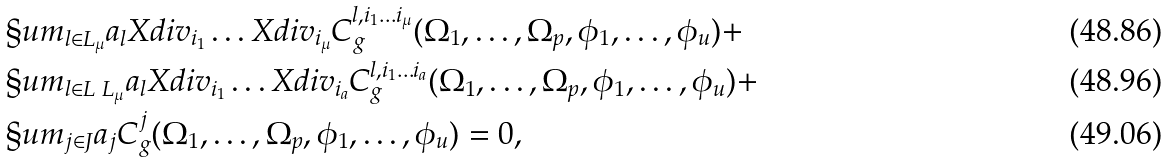Convert formula to latex. <formula><loc_0><loc_0><loc_500><loc_500>& \S u m _ { l \in L _ { \mu } } a _ { l } X d i v _ { i _ { 1 } } \dots X d i v _ { i _ { \mu } } C ^ { l , i _ { 1 } \dots i _ { \mu } } _ { g } ( \Omega _ { 1 } , \dots , \Omega _ { p } , \phi _ { 1 } , \dots , \phi _ { u } ) + \\ & \S u m _ { l \in L \ L _ { \mu } } a _ { l } X d i v _ { i _ { 1 } } \dots X d i v _ { i _ { a } } C ^ { l , i _ { 1 } \dots i _ { a } } _ { g } ( \Omega _ { 1 } , \dots , \Omega _ { p } , \phi _ { 1 } , \dots , \phi _ { u } ) + \\ & \S u m _ { j \in J } a _ { j } C ^ { j } _ { g } ( \Omega _ { 1 } , \dots , \Omega _ { p } , \phi _ { 1 } , \dots , \phi _ { u } ) = 0 ,</formula> 